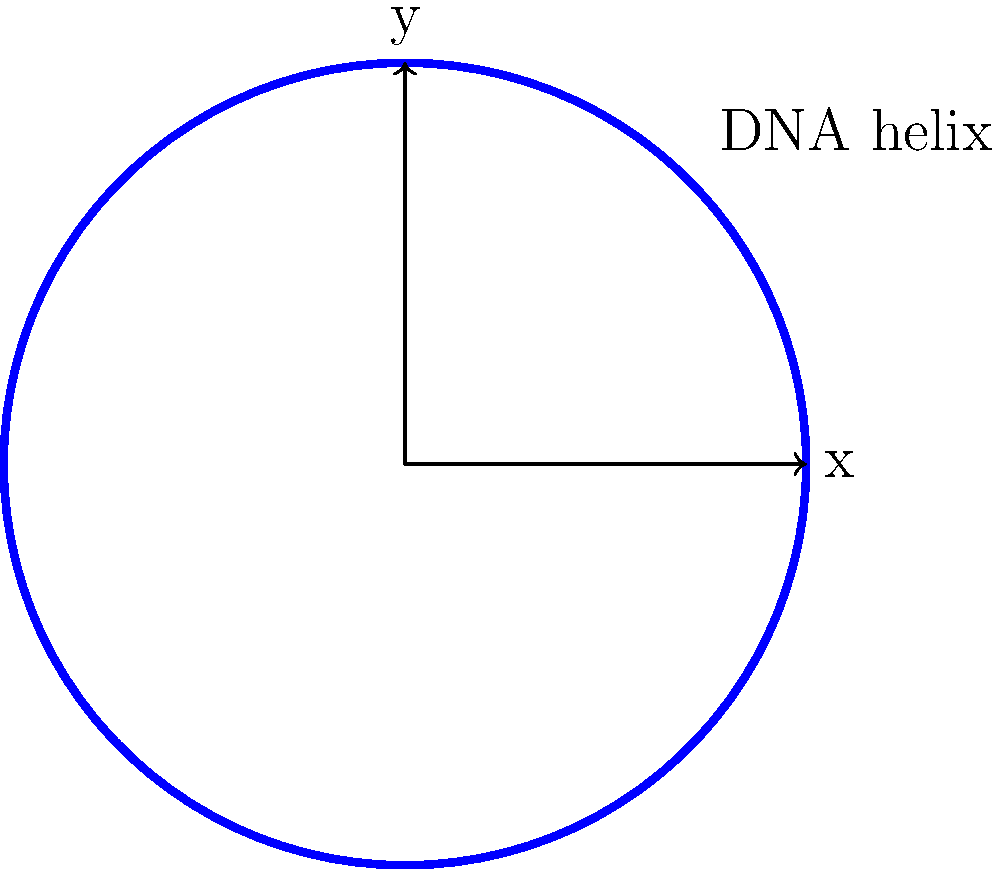In your genetic sequencing work on Roman Empire DNA samples, you're analyzing the structure of a DNA helix. The projection of the helix onto the xy-plane can be described by the parametric equations $x = 2\cos(t)$ and $y = 2\sin(t)$, where $t$ is in radians. If you consider a small arc of the helix corresponding to $\Delta t = 0.1$ radians, estimate the curvature of the helix at $t = \frac{\pi}{4}$ using trigonometric approximations. To estimate the curvature of the DNA helix, we'll follow these steps:

1) The curvature $\kappa$ is given by the formula:

   $$\kappa = \frac{|\dot{x}\ddot{y} - \dot{y}\ddot{x}|}{(\dot{x}^2 + \dot{y}^2)^{3/2}}$$

2) Calculate the first derivatives:
   $$\dot{x} = -2\sin(t)$$
   $$\dot{y} = 2\cos(t)$$

3) Calculate the second derivatives:
   $$\ddot{x} = -2\cos(t)$$
   $$\ddot{y} = -2\sin(t)$$

4) At $t = \frac{\pi}{4}$:
   $$\dot{x} = -2\sin(\frac{\pi}{4}) = -\sqrt{2}$$
   $$\dot{y} = 2\cos(\frac{\pi}{4}) = \sqrt{2}$$
   $$\ddot{x} = -2\cos(\frac{\pi}{4}) = -\sqrt{2}$$
   $$\ddot{y} = -2\sin(\frac{\pi}{4}) = -\sqrt{2}$$

5) Substitute into the curvature formula:

   $$\kappa = \frac{|(-\sqrt{2})(-\sqrt{2}) - (\sqrt{2})(-\sqrt{2})|}{((-\sqrt{2})^2 + (\sqrt{2})^2)^{3/2}}$$

6) Simplify:
   $$\kappa = \frac{|2 + 2|}{(4)^{3/2}} = \frac{4}{8} = 0.5$$

Therefore, the estimated curvature of the DNA helix at $t = \frac{\pi}{4}$ is 0.5.
Answer: 0.5 